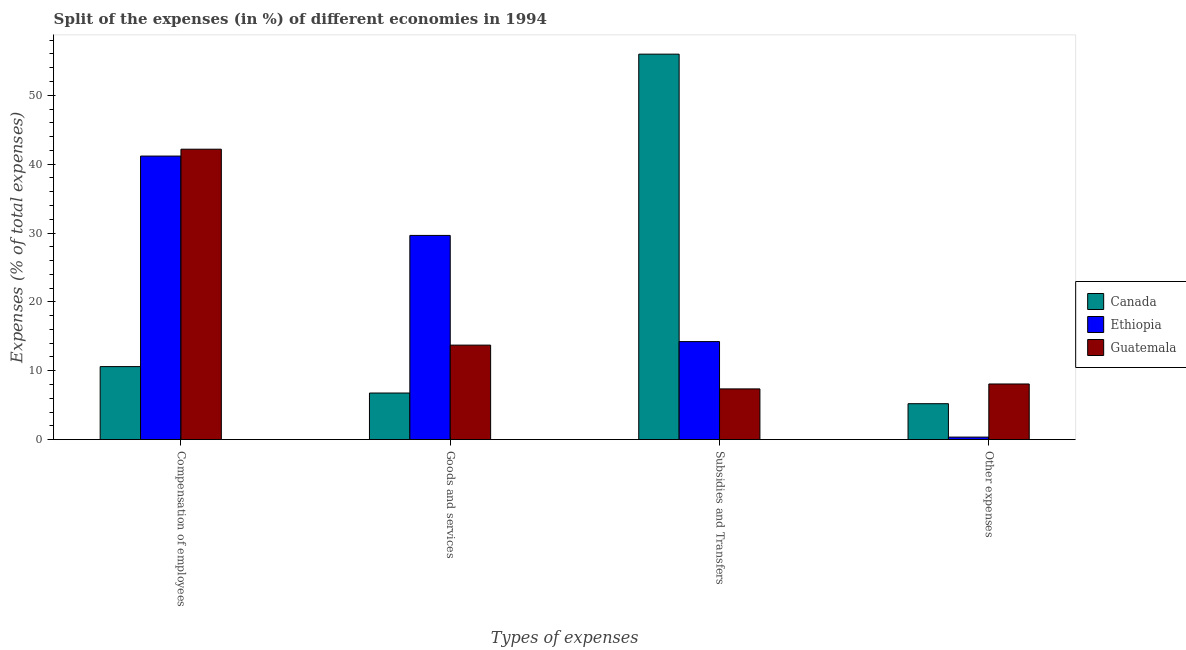How many different coloured bars are there?
Your response must be concise. 3. How many bars are there on the 1st tick from the left?
Offer a very short reply. 3. What is the label of the 2nd group of bars from the left?
Give a very brief answer. Goods and services. What is the percentage of amount spent on goods and services in Guatemala?
Make the answer very short. 13.72. Across all countries, what is the maximum percentage of amount spent on subsidies?
Your answer should be compact. 55.98. Across all countries, what is the minimum percentage of amount spent on other expenses?
Provide a short and direct response. 0.36. In which country was the percentage of amount spent on other expenses minimum?
Keep it short and to the point. Ethiopia. What is the total percentage of amount spent on goods and services in the graph?
Give a very brief answer. 50.14. What is the difference between the percentage of amount spent on subsidies in Canada and that in Ethiopia?
Provide a short and direct response. 41.74. What is the difference between the percentage of amount spent on goods and services in Guatemala and the percentage of amount spent on other expenses in Canada?
Make the answer very short. 8.51. What is the average percentage of amount spent on compensation of employees per country?
Make the answer very short. 31.32. What is the difference between the percentage of amount spent on compensation of employees and percentage of amount spent on other expenses in Canada?
Offer a terse response. 5.39. What is the ratio of the percentage of amount spent on compensation of employees in Guatemala to that in Ethiopia?
Provide a short and direct response. 1.02. Is the percentage of amount spent on other expenses in Canada less than that in Guatemala?
Provide a short and direct response. Yes. Is the difference between the percentage of amount spent on subsidies in Guatemala and Ethiopia greater than the difference between the percentage of amount spent on compensation of employees in Guatemala and Ethiopia?
Give a very brief answer. No. What is the difference between the highest and the second highest percentage of amount spent on other expenses?
Offer a terse response. 2.86. What is the difference between the highest and the lowest percentage of amount spent on goods and services?
Provide a short and direct response. 22.89. In how many countries, is the percentage of amount spent on other expenses greater than the average percentage of amount spent on other expenses taken over all countries?
Your response must be concise. 2. Is it the case that in every country, the sum of the percentage of amount spent on goods and services and percentage of amount spent on compensation of employees is greater than the sum of percentage of amount spent on subsidies and percentage of amount spent on other expenses?
Give a very brief answer. No. What does the 3rd bar from the left in Compensation of employees represents?
Offer a terse response. Guatemala. What does the 3rd bar from the right in Goods and services represents?
Your answer should be compact. Canada. How many bars are there?
Ensure brevity in your answer.  12. Are all the bars in the graph horizontal?
Your answer should be compact. No. Where does the legend appear in the graph?
Make the answer very short. Center right. How many legend labels are there?
Make the answer very short. 3. How are the legend labels stacked?
Keep it short and to the point. Vertical. What is the title of the graph?
Give a very brief answer. Split of the expenses (in %) of different economies in 1994. What is the label or title of the X-axis?
Your answer should be compact. Types of expenses. What is the label or title of the Y-axis?
Ensure brevity in your answer.  Expenses (% of total expenses). What is the Expenses (% of total expenses) in Canada in Compensation of employees?
Your response must be concise. 10.6. What is the Expenses (% of total expenses) of Ethiopia in Compensation of employees?
Your answer should be very brief. 41.18. What is the Expenses (% of total expenses) in Guatemala in Compensation of employees?
Ensure brevity in your answer.  42.17. What is the Expenses (% of total expenses) in Canada in Goods and services?
Your answer should be very brief. 6.77. What is the Expenses (% of total expenses) in Ethiopia in Goods and services?
Ensure brevity in your answer.  29.65. What is the Expenses (% of total expenses) in Guatemala in Goods and services?
Offer a very short reply. 13.72. What is the Expenses (% of total expenses) of Canada in Subsidies and Transfers?
Your answer should be very brief. 55.98. What is the Expenses (% of total expenses) of Ethiopia in Subsidies and Transfers?
Offer a very short reply. 14.23. What is the Expenses (% of total expenses) of Guatemala in Subsidies and Transfers?
Offer a terse response. 7.36. What is the Expenses (% of total expenses) of Canada in Other expenses?
Offer a terse response. 5.22. What is the Expenses (% of total expenses) of Ethiopia in Other expenses?
Provide a succinct answer. 0.36. What is the Expenses (% of total expenses) of Guatemala in Other expenses?
Offer a terse response. 8.08. Across all Types of expenses, what is the maximum Expenses (% of total expenses) in Canada?
Provide a succinct answer. 55.98. Across all Types of expenses, what is the maximum Expenses (% of total expenses) of Ethiopia?
Give a very brief answer. 41.18. Across all Types of expenses, what is the maximum Expenses (% of total expenses) in Guatemala?
Make the answer very short. 42.17. Across all Types of expenses, what is the minimum Expenses (% of total expenses) of Canada?
Provide a short and direct response. 5.22. Across all Types of expenses, what is the minimum Expenses (% of total expenses) in Ethiopia?
Give a very brief answer. 0.36. Across all Types of expenses, what is the minimum Expenses (% of total expenses) of Guatemala?
Offer a very short reply. 7.36. What is the total Expenses (% of total expenses) in Canada in the graph?
Your answer should be compact. 78.56. What is the total Expenses (% of total expenses) of Ethiopia in the graph?
Your response must be concise. 85.43. What is the total Expenses (% of total expenses) in Guatemala in the graph?
Your response must be concise. 71.33. What is the difference between the Expenses (% of total expenses) in Canada in Compensation of employees and that in Goods and services?
Your response must be concise. 3.84. What is the difference between the Expenses (% of total expenses) of Ethiopia in Compensation of employees and that in Goods and services?
Provide a short and direct response. 11.52. What is the difference between the Expenses (% of total expenses) in Guatemala in Compensation of employees and that in Goods and services?
Keep it short and to the point. 28.45. What is the difference between the Expenses (% of total expenses) of Canada in Compensation of employees and that in Subsidies and Transfers?
Your answer should be very brief. -45.37. What is the difference between the Expenses (% of total expenses) of Ethiopia in Compensation of employees and that in Subsidies and Transfers?
Offer a terse response. 26.94. What is the difference between the Expenses (% of total expenses) of Guatemala in Compensation of employees and that in Subsidies and Transfers?
Offer a very short reply. 34.81. What is the difference between the Expenses (% of total expenses) in Canada in Compensation of employees and that in Other expenses?
Keep it short and to the point. 5.39. What is the difference between the Expenses (% of total expenses) in Ethiopia in Compensation of employees and that in Other expenses?
Your answer should be compact. 40.81. What is the difference between the Expenses (% of total expenses) in Guatemala in Compensation of employees and that in Other expenses?
Provide a succinct answer. 34.09. What is the difference between the Expenses (% of total expenses) of Canada in Goods and services and that in Subsidies and Transfers?
Your response must be concise. -49.21. What is the difference between the Expenses (% of total expenses) in Ethiopia in Goods and services and that in Subsidies and Transfers?
Your answer should be very brief. 15.42. What is the difference between the Expenses (% of total expenses) of Guatemala in Goods and services and that in Subsidies and Transfers?
Offer a terse response. 6.36. What is the difference between the Expenses (% of total expenses) in Canada in Goods and services and that in Other expenses?
Make the answer very short. 1.55. What is the difference between the Expenses (% of total expenses) of Ethiopia in Goods and services and that in Other expenses?
Your answer should be very brief. 29.29. What is the difference between the Expenses (% of total expenses) in Guatemala in Goods and services and that in Other expenses?
Ensure brevity in your answer.  5.64. What is the difference between the Expenses (% of total expenses) in Canada in Subsidies and Transfers and that in Other expenses?
Your answer should be compact. 50.76. What is the difference between the Expenses (% of total expenses) in Ethiopia in Subsidies and Transfers and that in Other expenses?
Offer a terse response. 13.87. What is the difference between the Expenses (% of total expenses) in Guatemala in Subsidies and Transfers and that in Other expenses?
Your answer should be compact. -0.71. What is the difference between the Expenses (% of total expenses) of Canada in Compensation of employees and the Expenses (% of total expenses) of Ethiopia in Goods and services?
Provide a succinct answer. -19.05. What is the difference between the Expenses (% of total expenses) in Canada in Compensation of employees and the Expenses (% of total expenses) in Guatemala in Goods and services?
Make the answer very short. -3.12. What is the difference between the Expenses (% of total expenses) in Ethiopia in Compensation of employees and the Expenses (% of total expenses) in Guatemala in Goods and services?
Ensure brevity in your answer.  27.45. What is the difference between the Expenses (% of total expenses) in Canada in Compensation of employees and the Expenses (% of total expenses) in Ethiopia in Subsidies and Transfers?
Keep it short and to the point. -3.63. What is the difference between the Expenses (% of total expenses) in Canada in Compensation of employees and the Expenses (% of total expenses) in Guatemala in Subsidies and Transfers?
Your answer should be compact. 3.24. What is the difference between the Expenses (% of total expenses) in Ethiopia in Compensation of employees and the Expenses (% of total expenses) in Guatemala in Subsidies and Transfers?
Give a very brief answer. 33.81. What is the difference between the Expenses (% of total expenses) of Canada in Compensation of employees and the Expenses (% of total expenses) of Ethiopia in Other expenses?
Your answer should be compact. 10.24. What is the difference between the Expenses (% of total expenses) in Canada in Compensation of employees and the Expenses (% of total expenses) in Guatemala in Other expenses?
Your answer should be compact. 2.52. What is the difference between the Expenses (% of total expenses) in Ethiopia in Compensation of employees and the Expenses (% of total expenses) in Guatemala in Other expenses?
Make the answer very short. 33.1. What is the difference between the Expenses (% of total expenses) of Canada in Goods and services and the Expenses (% of total expenses) of Ethiopia in Subsidies and Transfers?
Provide a short and direct response. -7.47. What is the difference between the Expenses (% of total expenses) of Canada in Goods and services and the Expenses (% of total expenses) of Guatemala in Subsidies and Transfers?
Provide a short and direct response. -0.6. What is the difference between the Expenses (% of total expenses) of Ethiopia in Goods and services and the Expenses (% of total expenses) of Guatemala in Subsidies and Transfers?
Provide a short and direct response. 22.29. What is the difference between the Expenses (% of total expenses) in Canada in Goods and services and the Expenses (% of total expenses) in Ethiopia in Other expenses?
Give a very brief answer. 6.4. What is the difference between the Expenses (% of total expenses) in Canada in Goods and services and the Expenses (% of total expenses) in Guatemala in Other expenses?
Provide a short and direct response. -1.31. What is the difference between the Expenses (% of total expenses) of Ethiopia in Goods and services and the Expenses (% of total expenses) of Guatemala in Other expenses?
Ensure brevity in your answer.  21.58. What is the difference between the Expenses (% of total expenses) of Canada in Subsidies and Transfers and the Expenses (% of total expenses) of Ethiopia in Other expenses?
Ensure brevity in your answer.  55.61. What is the difference between the Expenses (% of total expenses) in Canada in Subsidies and Transfers and the Expenses (% of total expenses) in Guatemala in Other expenses?
Give a very brief answer. 47.9. What is the difference between the Expenses (% of total expenses) in Ethiopia in Subsidies and Transfers and the Expenses (% of total expenses) in Guatemala in Other expenses?
Provide a succinct answer. 6.16. What is the average Expenses (% of total expenses) of Canada per Types of expenses?
Give a very brief answer. 19.64. What is the average Expenses (% of total expenses) in Ethiopia per Types of expenses?
Keep it short and to the point. 21.36. What is the average Expenses (% of total expenses) of Guatemala per Types of expenses?
Your answer should be very brief. 17.83. What is the difference between the Expenses (% of total expenses) in Canada and Expenses (% of total expenses) in Ethiopia in Compensation of employees?
Provide a succinct answer. -30.57. What is the difference between the Expenses (% of total expenses) of Canada and Expenses (% of total expenses) of Guatemala in Compensation of employees?
Make the answer very short. -31.57. What is the difference between the Expenses (% of total expenses) of Ethiopia and Expenses (% of total expenses) of Guatemala in Compensation of employees?
Offer a terse response. -1. What is the difference between the Expenses (% of total expenses) of Canada and Expenses (% of total expenses) of Ethiopia in Goods and services?
Keep it short and to the point. -22.89. What is the difference between the Expenses (% of total expenses) of Canada and Expenses (% of total expenses) of Guatemala in Goods and services?
Provide a succinct answer. -6.96. What is the difference between the Expenses (% of total expenses) in Ethiopia and Expenses (% of total expenses) in Guatemala in Goods and services?
Provide a short and direct response. 15.93. What is the difference between the Expenses (% of total expenses) in Canada and Expenses (% of total expenses) in Ethiopia in Subsidies and Transfers?
Give a very brief answer. 41.74. What is the difference between the Expenses (% of total expenses) in Canada and Expenses (% of total expenses) in Guatemala in Subsidies and Transfers?
Offer a terse response. 48.61. What is the difference between the Expenses (% of total expenses) in Ethiopia and Expenses (% of total expenses) in Guatemala in Subsidies and Transfers?
Make the answer very short. 6.87. What is the difference between the Expenses (% of total expenses) of Canada and Expenses (% of total expenses) of Ethiopia in Other expenses?
Keep it short and to the point. 4.85. What is the difference between the Expenses (% of total expenses) of Canada and Expenses (% of total expenses) of Guatemala in Other expenses?
Provide a short and direct response. -2.86. What is the difference between the Expenses (% of total expenses) of Ethiopia and Expenses (% of total expenses) of Guatemala in Other expenses?
Ensure brevity in your answer.  -7.71. What is the ratio of the Expenses (% of total expenses) in Canada in Compensation of employees to that in Goods and services?
Provide a short and direct response. 1.57. What is the ratio of the Expenses (% of total expenses) of Ethiopia in Compensation of employees to that in Goods and services?
Provide a short and direct response. 1.39. What is the ratio of the Expenses (% of total expenses) in Guatemala in Compensation of employees to that in Goods and services?
Give a very brief answer. 3.07. What is the ratio of the Expenses (% of total expenses) in Canada in Compensation of employees to that in Subsidies and Transfers?
Your answer should be very brief. 0.19. What is the ratio of the Expenses (% of total expenses) of Ethiopia in Compensation of employees to that in Subsidies and Transfers?
Your response must be concise. 2.89. What is the ratio of the Expenses (% of total expenses) in Guatemala in Compensation of employees to that in Subsidies and Transfers?
Offer a terse response. 5.73. What is the ratio of the Expenses (% of total expenses) of Canada in Compensation of employees to that in Other expenses?
Give a very brief answer. 2.03. What is the ratio of the Expenses (% of total expenses) of Ethiopia in Compensation of employees to that in Other expenses?
Keep it short and to the point. 113.38. What is the ratio of the Expenses (% of total expenses) of Guatemala in Compensation of employees to that in Other expenses?
Offer a terse response. 5.22. What is the ratio of the Expenses (% of total expenses) in Canada in Goods and services to that in Subsidies and Transfers?
Give a very brief answer. 0.12. What is the ratio of the Expenses (% of total expenses) of Ethiopia in Goods and services to that in Subsidies and Transfers?
Provide a short and direct response. 2.08. What is the ratio of the Expenses (% of total expenses) of Guatemala in Goods and services to that in Subsidies and Transfers?
Your answer should be compact. 1.86. What is the ratio of the Expenses (% of total expenses) of Canada in Goods and services to that in Other expenses?
Your answer should be compact. 1.3. What is the ratio of the Expenses (% of total expenses) in Ethiopia in Goods and services to that in Other expenses?
Provide a succinct answer. 81.65. What is the ratio of the Expenses (% of total expenses) in Guatemala in Goods and services to that in Other expenses?
Provide a succinct answer. 1.7. What is the ratio of the Expenses (% of total expenses) in Canada in Subsidies and Transfers to that in Other expenses?
Offer a very short reply. 10.73. What is the ratio of the Expenses (% of total expenses) of Ethiopia in Subsidies and Transfers to that in Other expenses?
Your answer should be compact. 39.19. What is the ratio of the Expenses (% of total expenses) in Guatemala in Subsidies and Transfers to that in Other expenses?
Your answer should be very brief. 0.91. What is the difference between the highest and the second highest Expenses (% of total expenses) in Canada?
Offer a terse response. 45.37. What is the difference between the highest and the second highest Expenses (% of total expenses) in Ethiopia?
Your answer should be very brief. 11.52. What is the difference between the highest and the second highest Expenses (% of total expenses) in Guatemala?
Provide a short and direct response. 28.45. What is the difference between the highest and the lowest Expenses (% of total expenses) in Canada?
Provide a short and direct response. 50.76. What is the difference between the highest and the lowest Expenses (% of total expenses) of Ethiopia?
Keep it short and to the point. 40.81. What is the difference between the highest and the lowest Expenses (% of total expenses) in Guatemala?
Give a very brief answer. 34.81. 